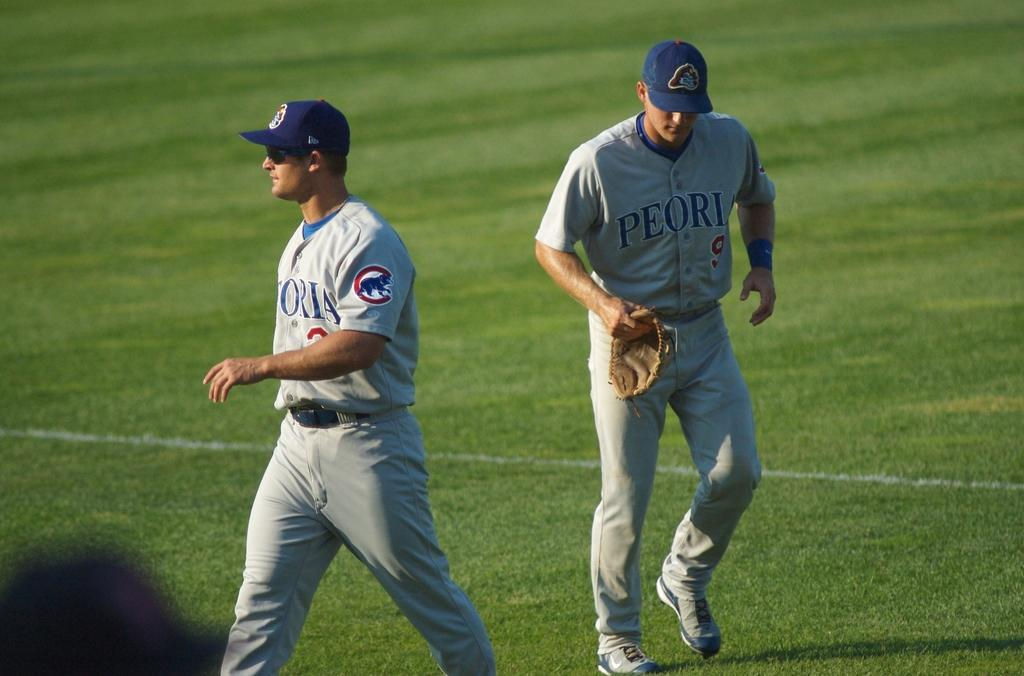<image>
Relay a brief, clear account of the picture shown. a couple players with the word Peori on their jersey 